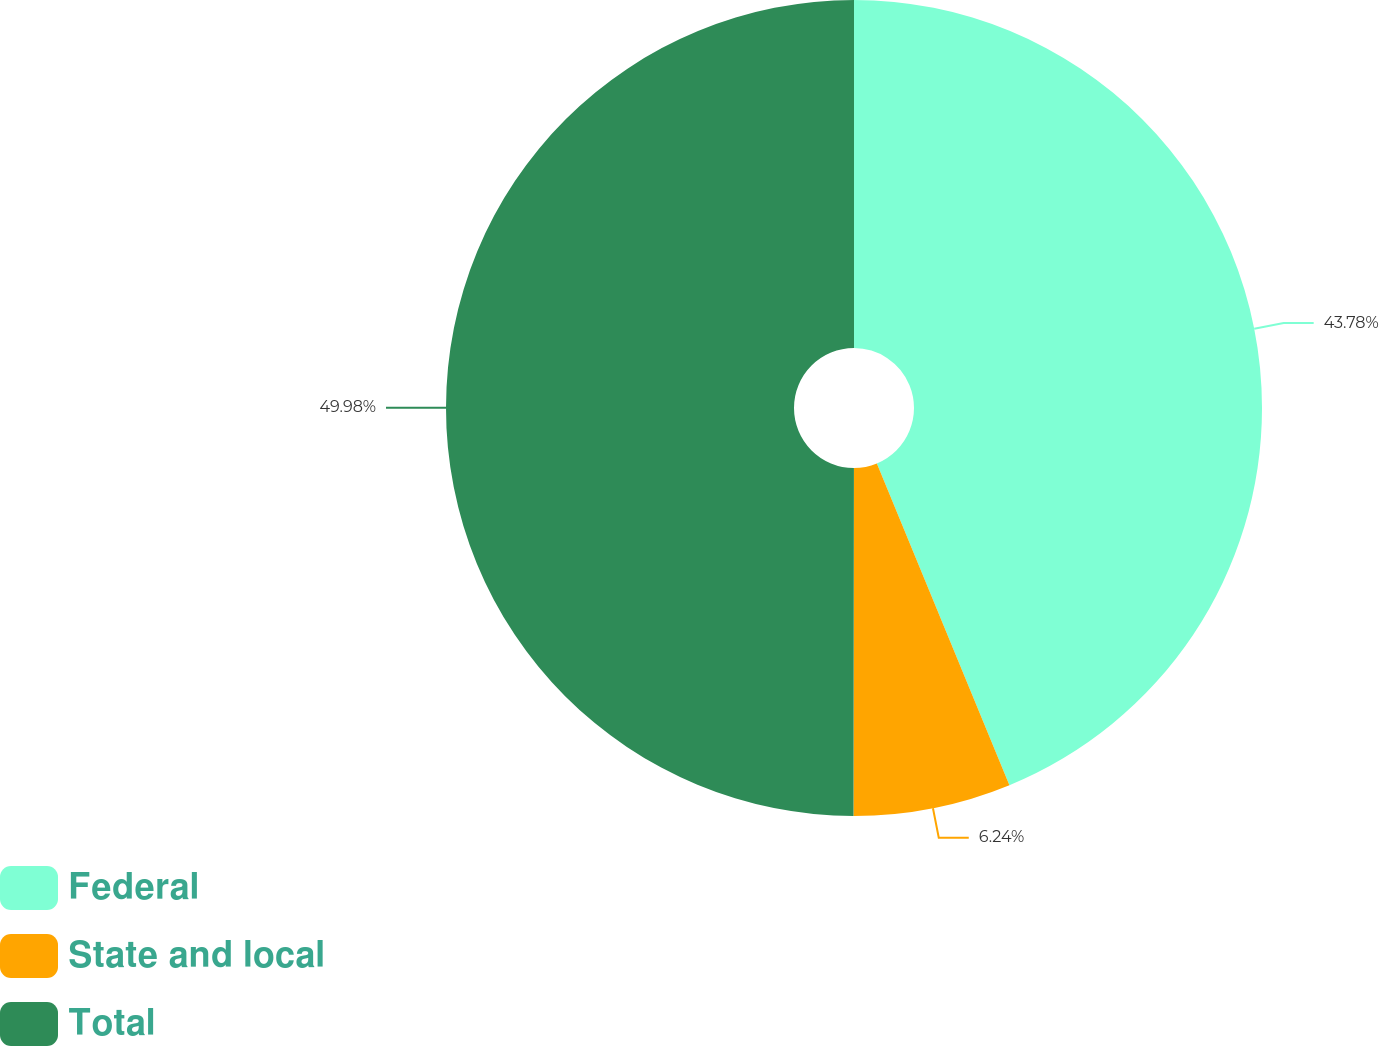Convert chart to OTSL. <chart><loc_0><loc_0><loc_500><loc_500><pie_chart><fcel>Federal<fcel>State and local<fcel>Total<nl><fcel>43.78%<fcel>6.24%<fcel>49.98%<nl></chart> 